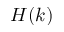Convert formula to latex. <formula><loc_0><loc_0><loc_500><loc_500>H ( k )</formula> 